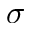Convert formula to latex. <formula><loc_0><loc_0><loc_500><loc_500>\sigma</formula> 